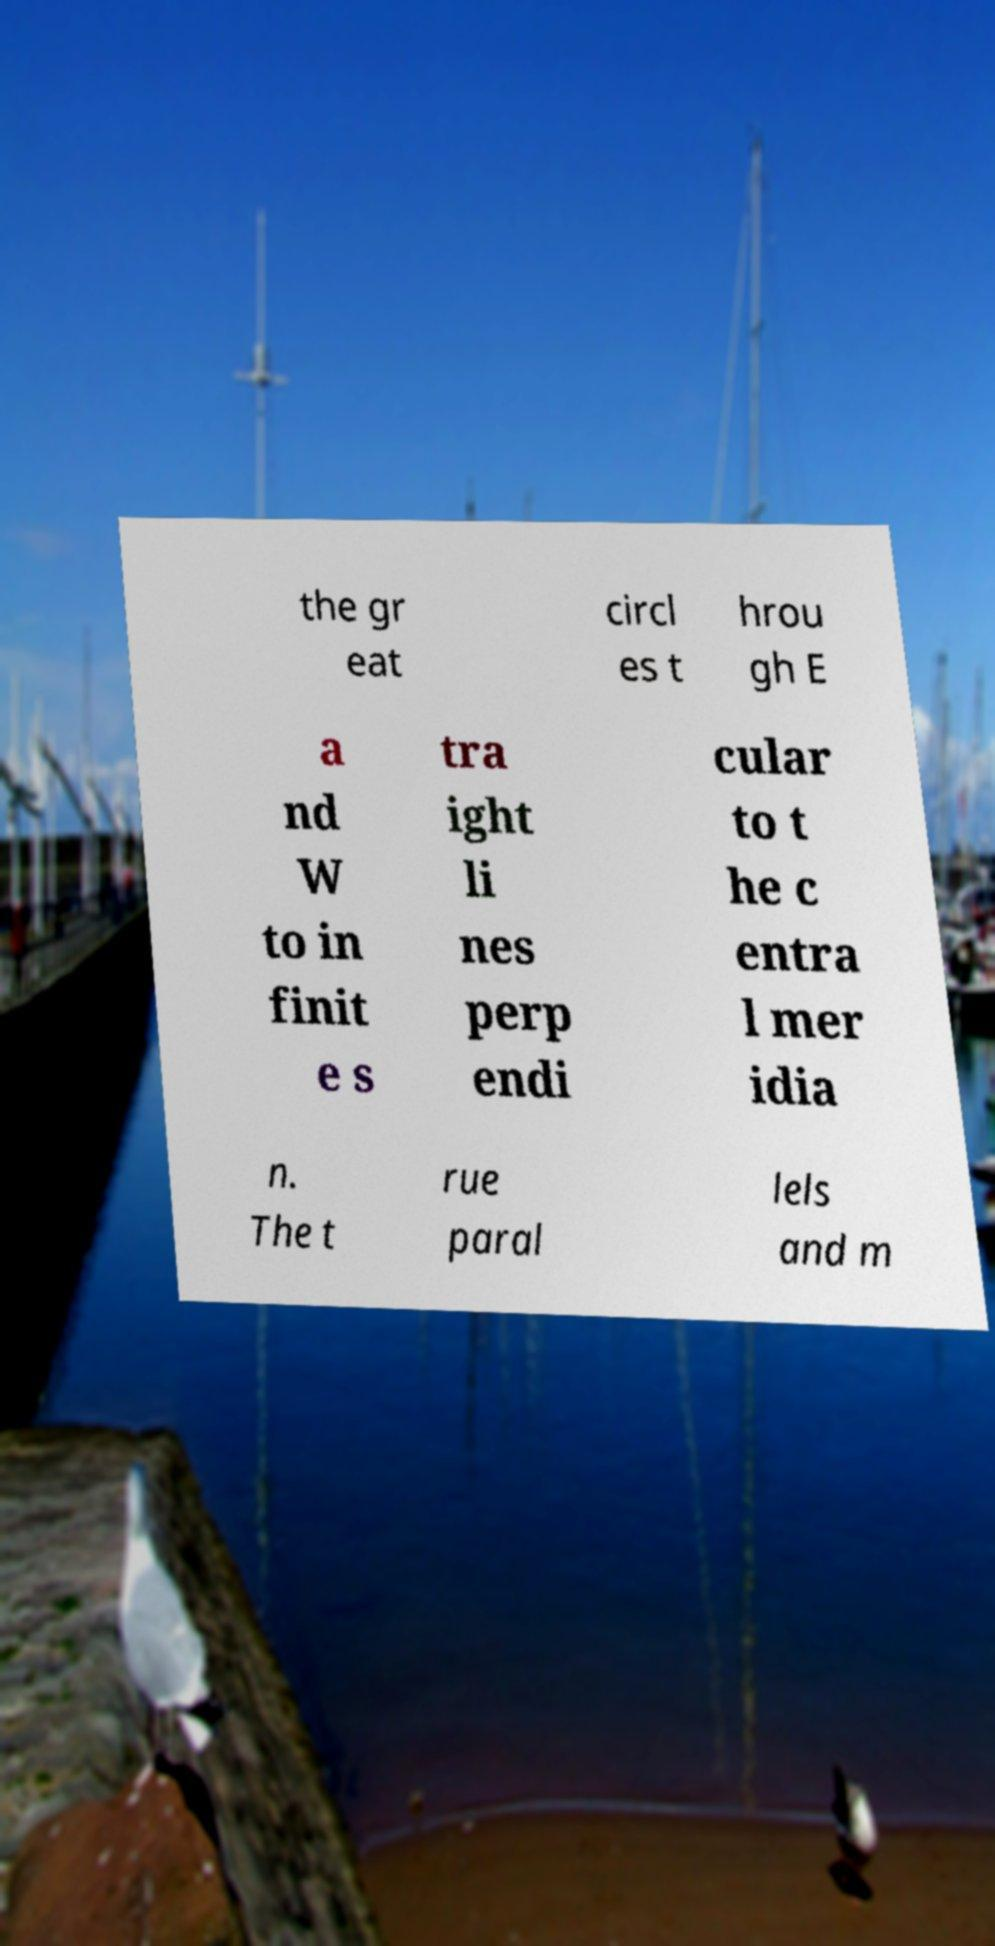There's text embedded in this image that I need extracted. Can you transcribe it verbatim? the gr eat circl es t hrou gh E a nd W to in finit e s tra ight li nes perp endi cular to t he c entra l mer idia n. The t rue paral lels and m 